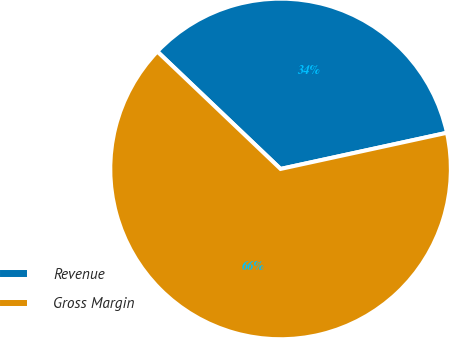Convert chart to OTSL. <chart><loc_0><loc_0><loc_500><loc_500><pie_chart><fcel>Revenue<fcel>Gross Margin<nl><fcel>34.48%<fcel>65.52%<nl></chart> 